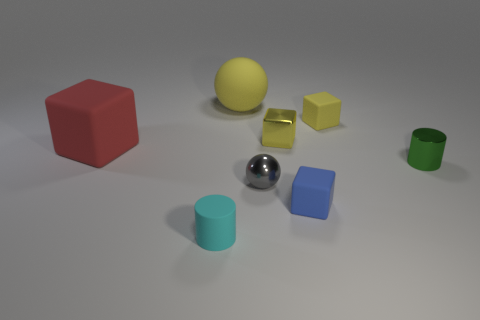Subtract all balls. How many objects are left? 6 Subtract 1 balls. How many balls are left? 1 Add 1 blue matte cubes. How many objects exist? 9 Subtract all red blocks. How many blocks are left? 3 Subtract 0 green spheres. How many objects are left? 8 Subtract all yellow balls. Subtract all red cubes. How many balls are left? 1 Subtract all blue spheres. How many yellow cubes are left? 2 Subtract all green things. Subtract all gray metal objects. How many objects are left? 6 Add 4 large red cubes. How many large red cubes are left? 5 Add 8 cyan things. How many cyan things exist? 9 